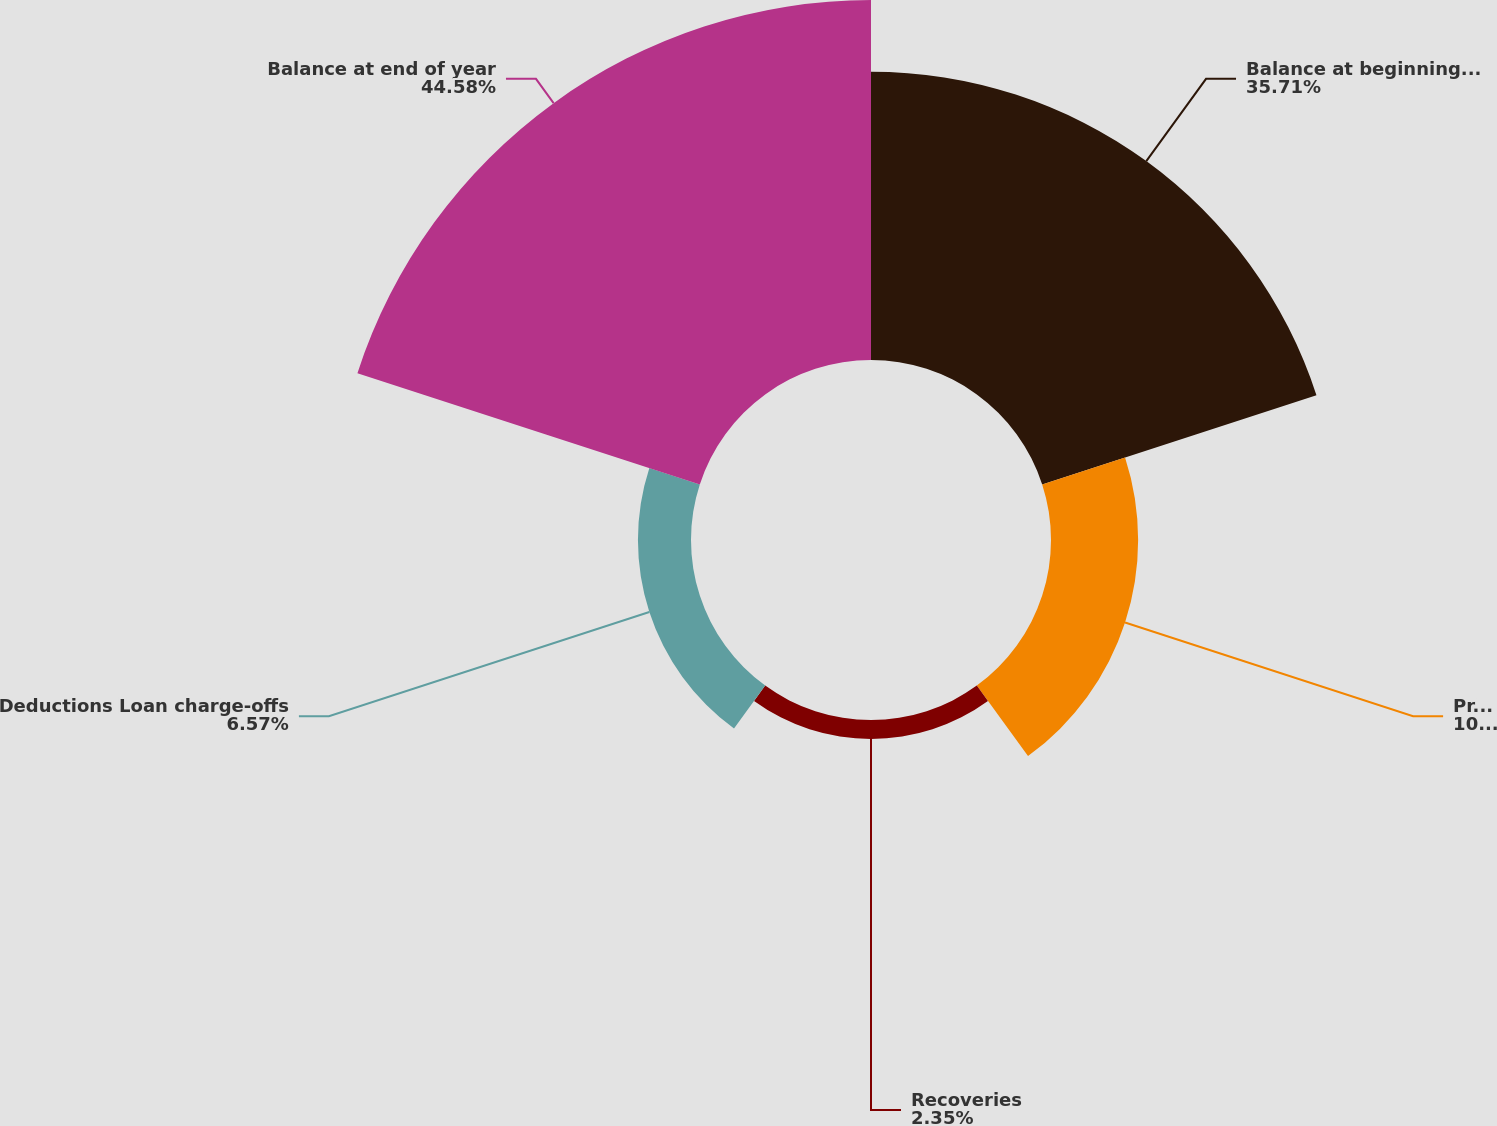<chart> <loc_0><loc_0><loc_500><loc_500><pie_chart><fcel>Balance at beginning of year<fcel>Provision for loan losses<fcel>Recoveries<fcel>Deductions Loan charge-offs<fcel>Balance at end of year<nl><fcel>35.71%<fcel>10.79%<fcel>2.35%<fcel>6.57%<fcel>44.58%<nl></chart> 